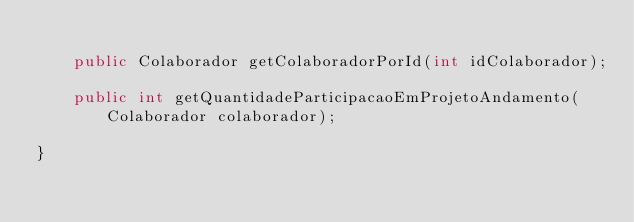<code> <loc_0><loc_0><loc_500><loc_500><_Java_>
	public Colaborador getColaboradorPorId(int idColaborador);

	public int getQuantidadeParticipacaoEmProjetoAndamento(Colaborador colaborador);

}
</code> 